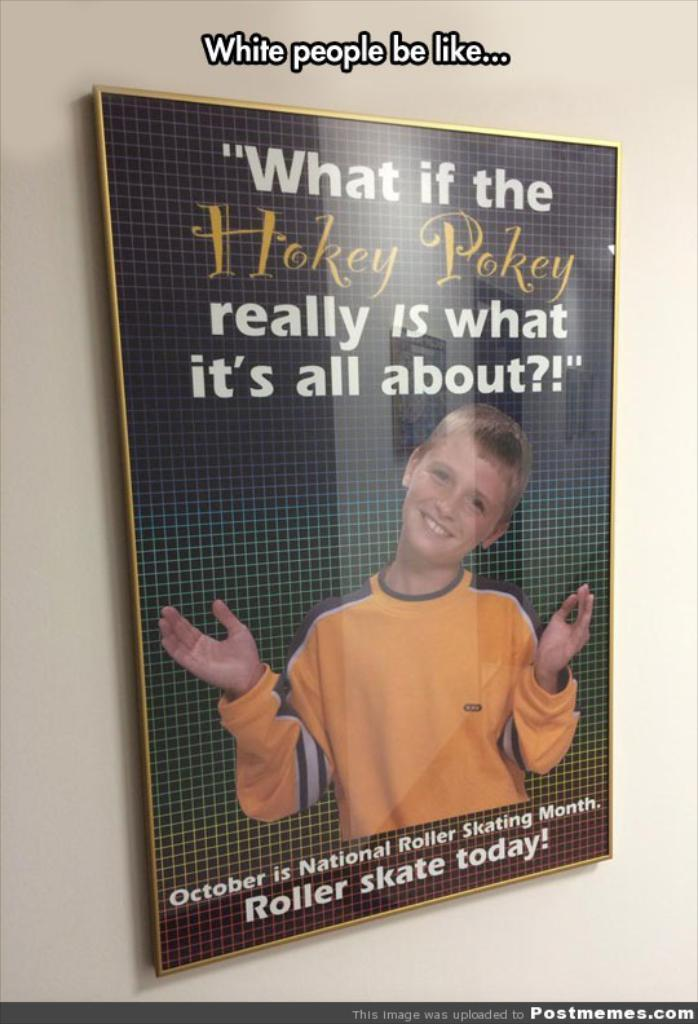<image>
Write a terse but informative summary of the picture. a book that says hokey pokey on it 